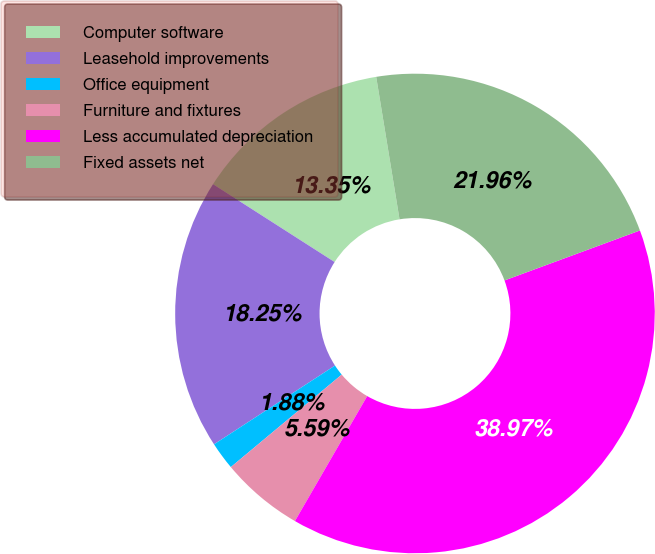<chart> <loc_0><loc_0><loc_500><loc_500><pie_chart><fcel>Computer software<fcel>Leasehold improvements<fcel>Office equipment<fcel>Furniture and fixtures<fcel>Less accumulated depreciation<fcel>Fixed assets net<nl><fcel>13.35%<fcel>18.25%<fcel>1.88%<fcel>5.59%<fcel>38.97%<fcel>21.96%<nl></chart> 